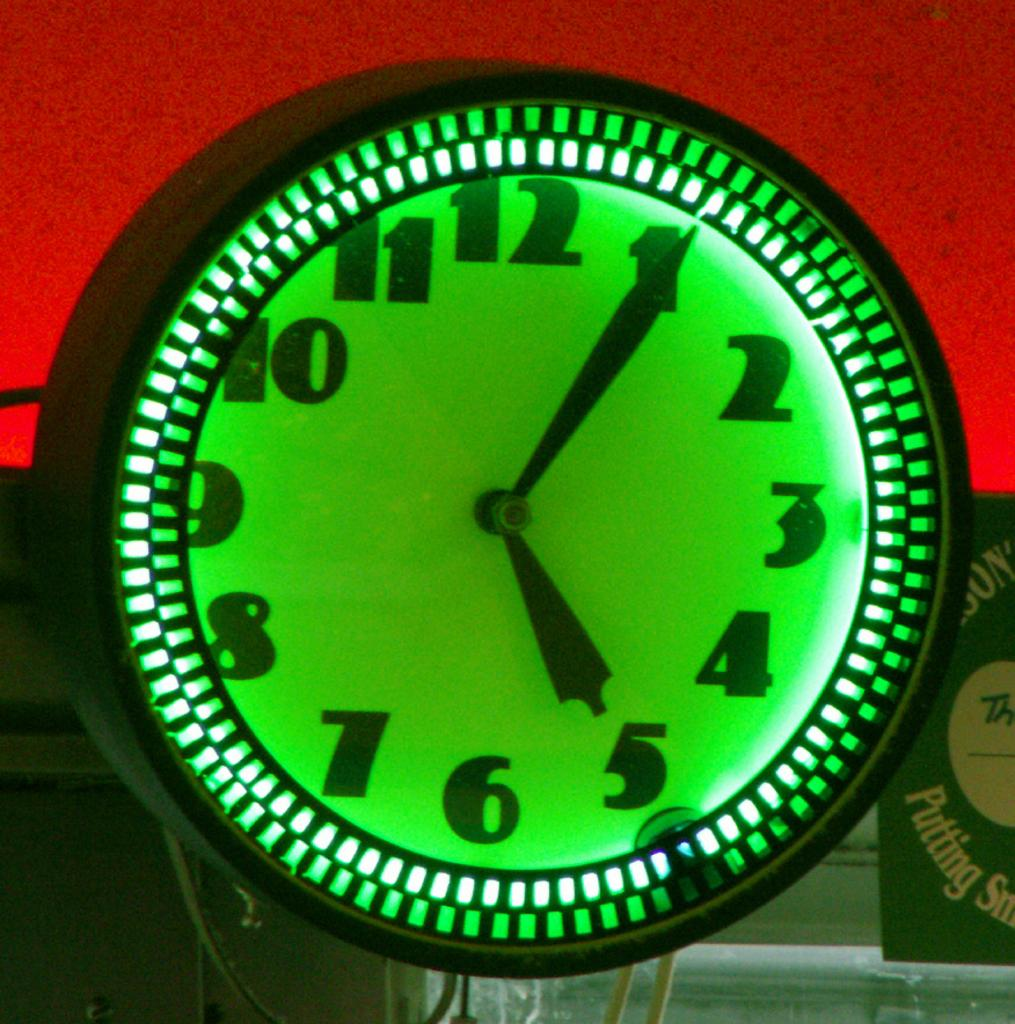Provide a one-sentence caption for the provided image. A green neon lit clock whose time reads 5:05 on its face. 